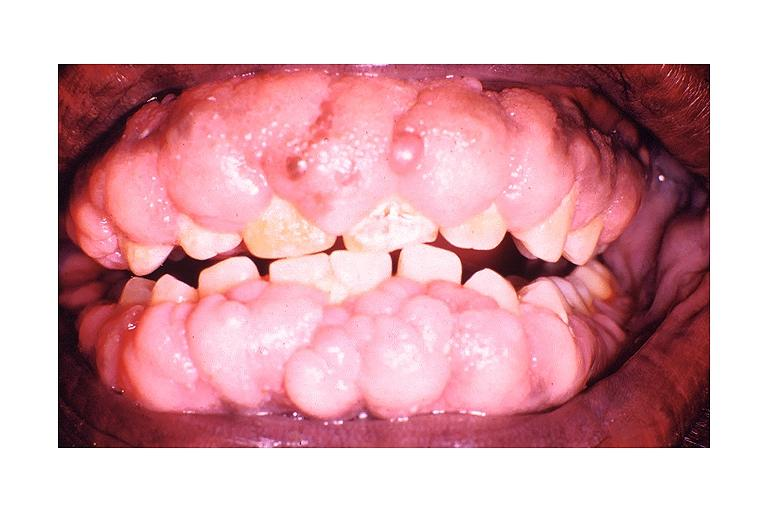s eosinophilic adenoma present?
Answer the question using a single word or phrase. No 